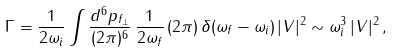<formula> <loc_0><loc_0><loc_500><loc_500>\Gamma = \frac { 1 } { 2 \omega _ { i } } \int \frac { d ^ { 6 } p _ { f _ { \perp } } } { ( 2 \pi ) ^ { 6 } } \, \frac { 1 } { 2 \omega _ { f } } \, ( 2 \pi ) \, \delta ( \omega _ { f } - \omega _ { i } ) \, | V | ^ { 2 } \sim \omega _ { i } ^ { 3 } \, | V | ^ { 2 } \, ,</formula> 